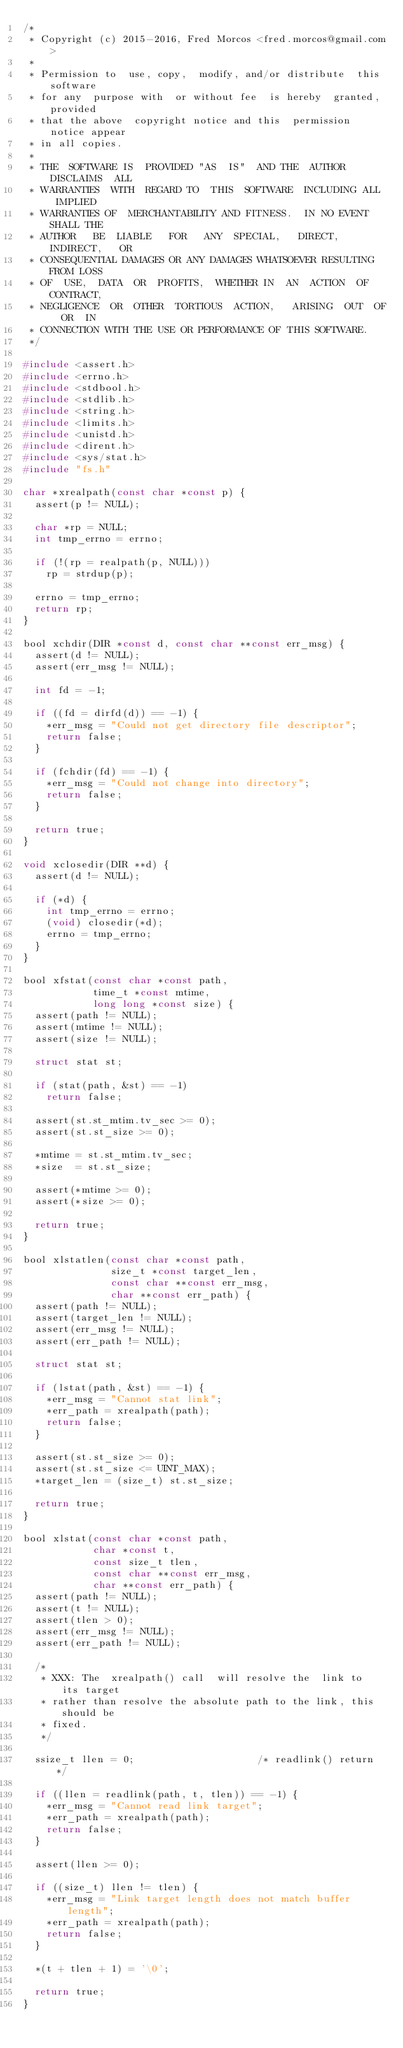Convert code to text. <code><loc_0><loc_0><loc_500><loc_500><_C_>/*
 * Copyright (c) 2015-2016, Fred Morcos <fred.morcos@gmail.com>
 *
 * Permission to  use, copy,  modify, and/or distribute  this software
 * for any  purpose with  or without fee  is hereby  granted, provided
 * that the above  copyright notice and this  permission notice appear
 * in all copies.
 *
 * THE  SOFTWARE IS  PROVIDED "AS  IS"  AND THE  AUTHOR DISCLAIMS  ALL
 * WARRANTIES  WITH  REGARD TO  THIS  SOFTWARE  INCLUDING ALL  IMPLIED
 * WARRANTIES OF  MERCHANTABILITY AND FITNESS.  IN NO EVENT  SHALL THE
 * AUTHOR   BE  LIABLE   FOR   ANY  SPECIAL,   DIRECT,  INDIRECT,   OR
 * CONSEQUENTIAL DAMAGES OR ANY DAMAGES WHATSOEVER RESULTING FROM LOSS
 * OF  USE,  DATA  OR  PROFITS,  WHETHER IN  AN  ACTION  OF  CONTRACT,
 * NEGLIGENCE  OR  OTHER  TORTIOUS  ACTION,   ARISING  OUT  OF  OR  IN
 * CONNECTION WITH THE USE OR PERFORMANCE OF THIS SOFTWARE.
 */

#include <assert.h>
#include <errno.h>
#include <stdbool.h>
#include <stdlib.h>
#include <string.h>
#include <limits.h>
#include <unistd.h>
#include <dirent.h>
#include <sys/stat.h>
#include "fs.h"

char *xrealpath(const char *const p) {
  assert(p != NULL);

  char *rp = NULL;
  int tmp_errno = errno;

  if (!(rp = realpath(p, NULL)))
    rp = strdup(p);

  errno = tmp_errno;
  return rp;
}

bool xchdir(DIR *const d, const char **const err_msg) {
  assert(d != NULL);
  assert(err_msg != NULL);

  int fd = -1;

  if ((fd = dirfd(d)) == -1) {
    *err_msg = "Could not get directory file descriptor";
    return false;
  }

  if (fchdir(fd) == -1) {
    *err_msg = "Could not change into directory";
    return false;
  }

  return true;
}

void xclosedir(DIR **d) {
  assert(d != NULL);

  if (*d) {
    int tmp_errno = errno;
    (void) closedir(*d);
    errno = tmp_errno;
  }
}

bool xfstat(const char *const path,
            time_t *const mtime,
            long long *const size) {
  assert(path != NULL);
  assert(mtime != NULL);
  assert(size != NULL);

  struct stat st;

  if (stat(path, &st) == -1)
    return false;

  assert(st.st_mtim.tv_sec >= 0);
  assert(st.st_size >= 0);

  *mtime = st.st_mtim.tv_sec;
  *size  = st.st_size;

  assert(*mtime >= 0);
  assert(*size >= 0);

  return true;
}

bool xlstatlen(const char *const path,
               size_t *const target_len,
               const char **const err_msg,
               char **const err_path) {
  assert(path != NULL);
  assert(target_len != NULL);
  assert(err_msg != NULL);
  assert(err_path != NULL);

  struct stat st;

  if (lstat(path, &st) == -1) {
    *err_msg = "Cannot stat link";
    *err_path = xrealpath(path);
    return false;
  }

  assert(st.st_size >= 0);
  assert(st.st_size <= UINT_MAX);
  *target_len = (size_t) st.st_size;

  return true;
}

bool xlstat(const char *const path,
            char *const t,
            const size_t tlen,
            const char **const err_msg,
            char **const err_path) {
  assert(path != NULL);
  assert(t != NULL);
  assert(tlen > 0);
  assert(err_msg != NULL);
  assert(err_path != NULL);

  /*
   * XXX: The  xrealpath() call  will resolve the  link to  its target
   * rather than resolve the absolute path to the link, this should be
   * fixed.
   */

  ssize_t llen = 0;                     /* readlink() return */

  if ((llen = readlink(path, t, tlen)) == -1) {
    *err_msg = "Cannot read link target";
    *err_path = xrealpath(path);
    return false;
  }

  assert(llen >= 0);

  if ((size_t) llen != tlen) {
    *err_msg = "Link target length does not match buffer length";
    *err_path = xrealpath(path);
    return false;
  }

  *(t + tlen + 1) = '\0';

  return true;
}
</code> 